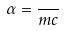<formula> <loc_0><loc_0><loc_500><loc_500>\alpha = \frac { } { m c }</formula> 